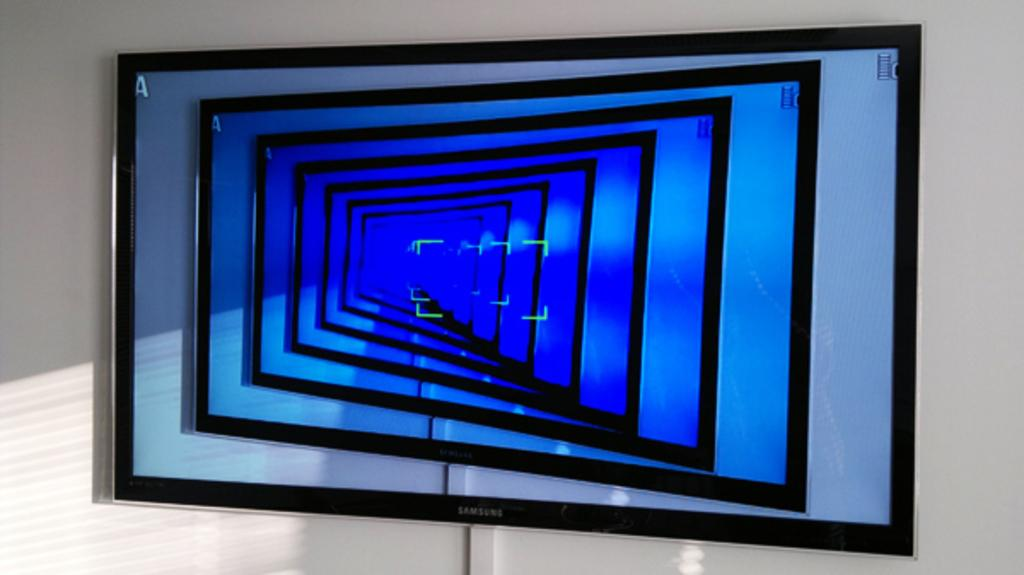What is on the wall in the image? There is a screen on the wall in the image. What type of music is the queen listening to on the screen in the image? There is no queen or music present in the image; it only features a screen on the wall. 